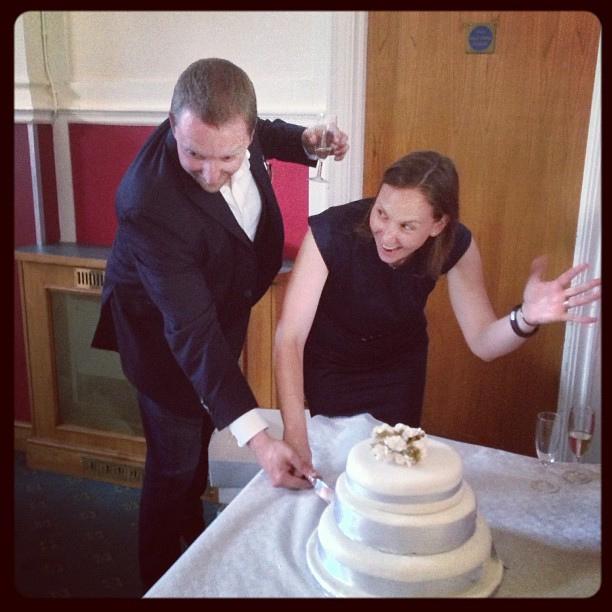Is this three layer cake a wedding cake?
Keep it brief. Yes. How many people are holding a wine glass?
Write a very short answer. 1. Is the lady wearing white dress?
Concise answer only. No. Does the cake look tasty?
Short answer required. Yes. 